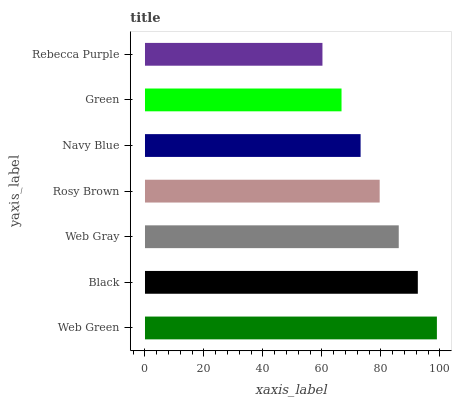Is Rebecca Purple the minimum?
Answer yes or no. Yes. Is Web Green the maximum?
Answer yes or no. Yes. Is Black the minimum?
Answer yes or no. No. Is Black the maximum?
Answer yes or no. No. Is Web Green greater than Black?
Answer yes or no. Yes. Is Black less than Web Green?
Answer yes or no. Yes. Is Black greater than Web Green?
Answer yes or no. No. Is Web Green less than Black?
Answer yes or no. No. Is Rosy Brown the high median?
Answer yes or no. Yes. Is Rosy Brown the low median?
Answer yes or no. Yes. Is Rebecca Purple the high median?
Answer yes or no. No. Is Black the low median?
Answer yes or no. No. 